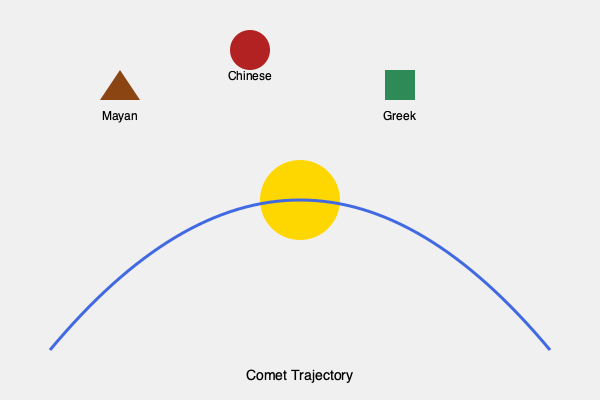Analyze the similarities in the mythological interpretations of comets across different ancient cultures as depicted in the image. How do these interpretations relate to the actual trajectory of comets, and what common themes emerge in their significance? To answer this question, we need to consider several aspects:

1. Comet trajectory: The image shows a parabolic path typical of comets, approaching from a distance, swinging around the Sun, and departing.

2. Cultural interpretations:
   a) Mayan: Represented by a triangle, possibly symbolizing a mountain or pyramid.
   b) Chinese: Depicted as a circle, potentially representing harmony or celestial bodies.
   c) Greek: Shown as a square, possibly indicating stability or earthly elements.

3. Common themes:
   a) Celestial nature: All cultures recognized comets as celestial phenomena.
   b) Rarity and significance: The distinct representations suggest comets were seen as unusual and important events.
   c) Directionality: The symbols are oriented towards the comet's path, indicating awareness of their movement.

4. Relation to actual trajectory:
   a) Sudden appearance: The comet's approach from deep space aligns with cultures viewing them as unexpected omens.
   b) Proximity to Sun: The trajectory's closest approach to the Sun might relate to interpretations of comets as mediators between heavenly and earthly realms.
   c) Departure: The comet's exit could be linked to ideas of transience or cyclical nature in mythologies.

5. Mythological significance:
   a) Messengers: Across cultures, comets were often seen as carrying divine messages.
   b) Harbingers: Their rare appearances were frequently interpreted as portents of significant events.
   c) Cosmic balance: The interaction with the Sun in the comet's path might symbolize interplay between cosmic forces.

The similarities in interpretations suggest a universal human tendency to ascribe meaning to celestial phenomena, despite cultural differences. The actual scientific understanding of comet trajectories provides a basis for understanding why these interpretations might have arisen and persisted across diverse civilizations.
Answer: Universal divine messengers symbolizing cosmic balance and significant events, inspired by their rare appearances and distinctive celestial paths. 